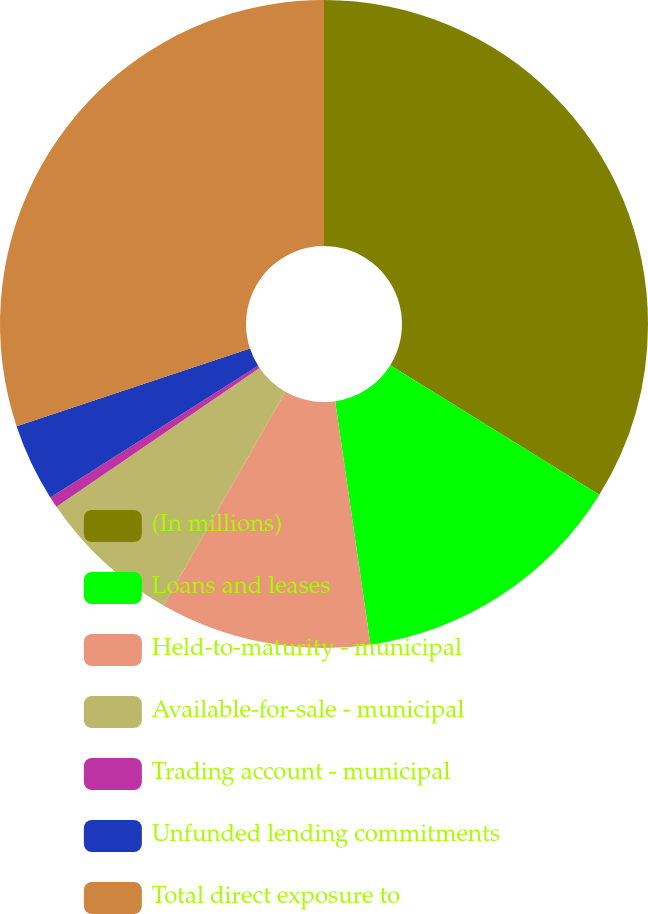<chart> <loc_0><loc_0><loc_500><loc_500><pie_chart><fcel>(In millions)<fcel>Loans and leases<fcel>Held-to-maturity - municipal<fcel>Available-for-sale - municipal<fcel>Trading account - municipal<fcel>Unfunded lending commitments<fcel>Total direct exposure to<nl><fcel>33.84%<fcel>13.87%<fcel>10.54%<fcel>7.21%<fcel>0.55%<fcel>3.88%<fcel>30.11%<nl></chart> 